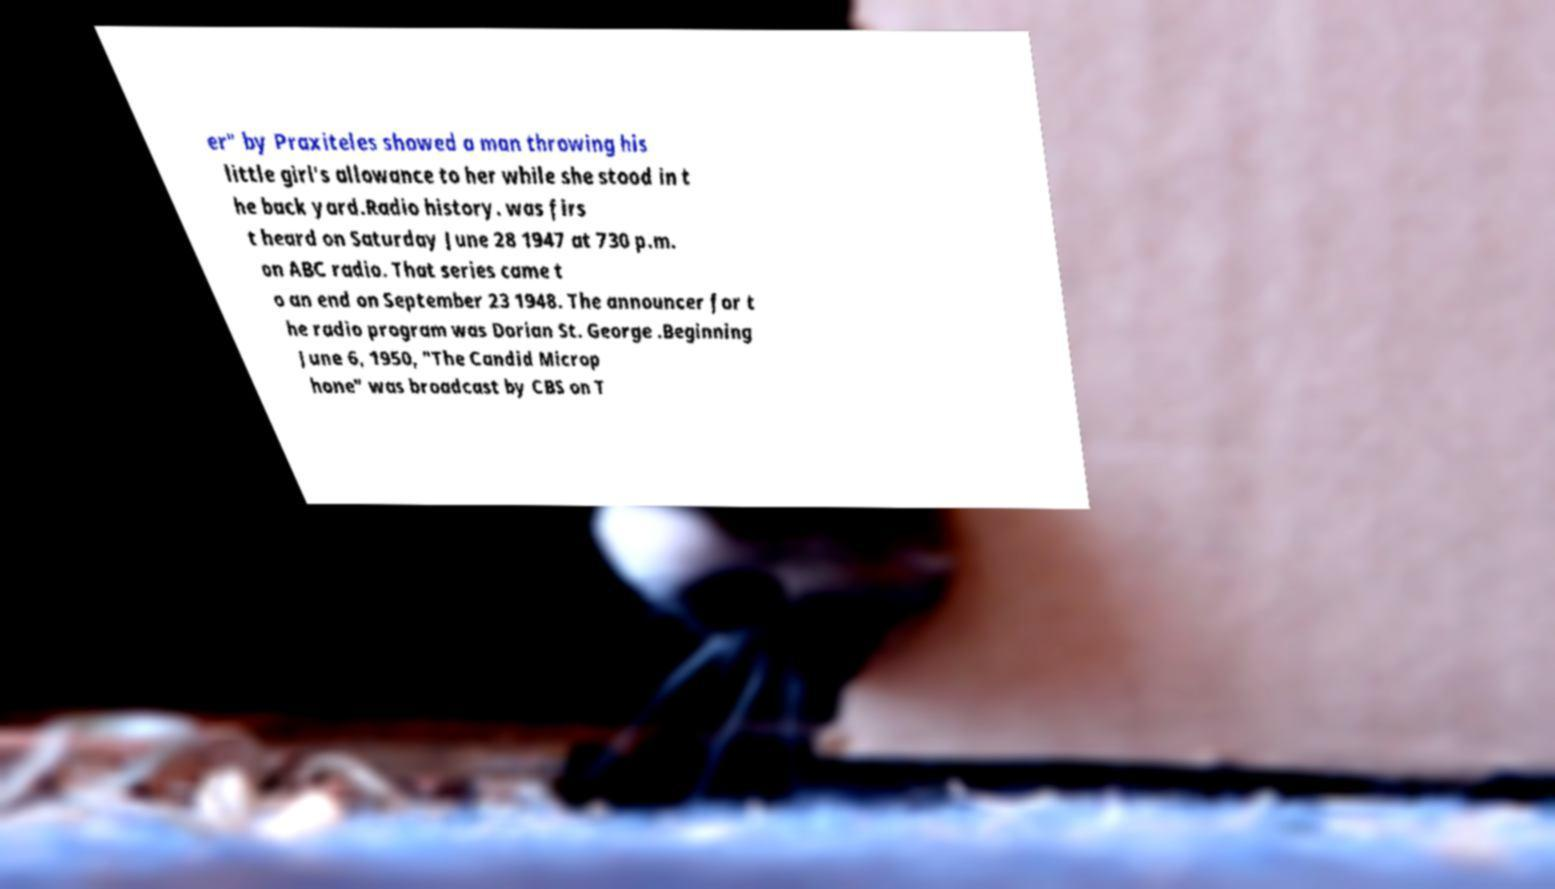Could you assist in decoding the text presented in this image and type it out clearly? er" by Praxiteles showed a man throwing his little girl's allowance to her while she stood in t he back yard.Radio history. was firs t heard on Saturday June 28 1947 at 730 p.m. on ABC radio. That series came t o an end on September 23 1948. The announcer for t he radio program was Dorian St. George .Beginning June 6, 1950, "The Candid Microp hone" was broadcast by CBS on T 